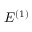<formula> <loc_0><loc_0><loc_500><loc_500>E ^ { ( 1 ) }</formula> 